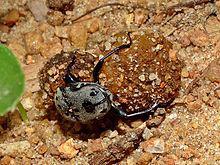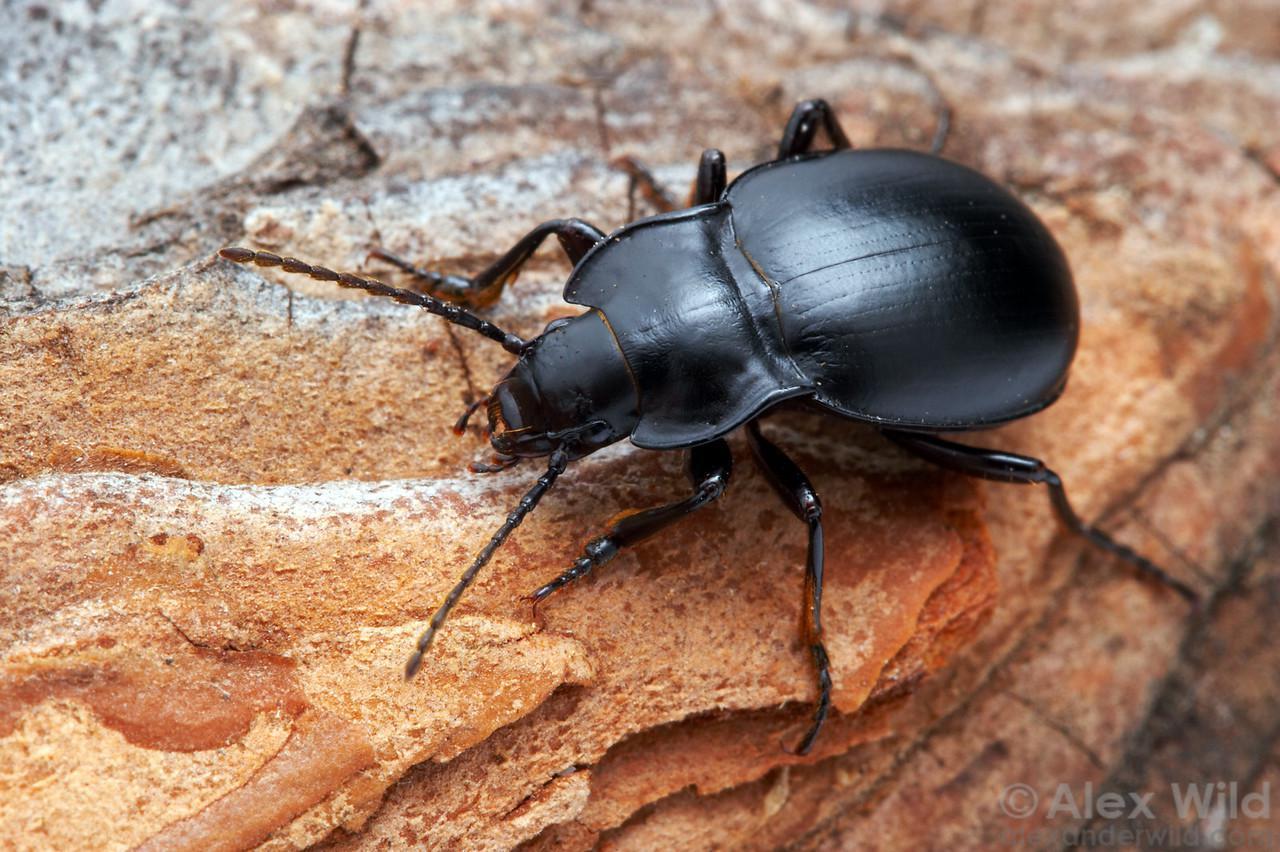The first image is the image on the left, the second image is the image on the right. Given the left and right images, does the statement "There is at least one black spot on the back of the insect in one of the images." hold true? Answer yes or no. Yes. 